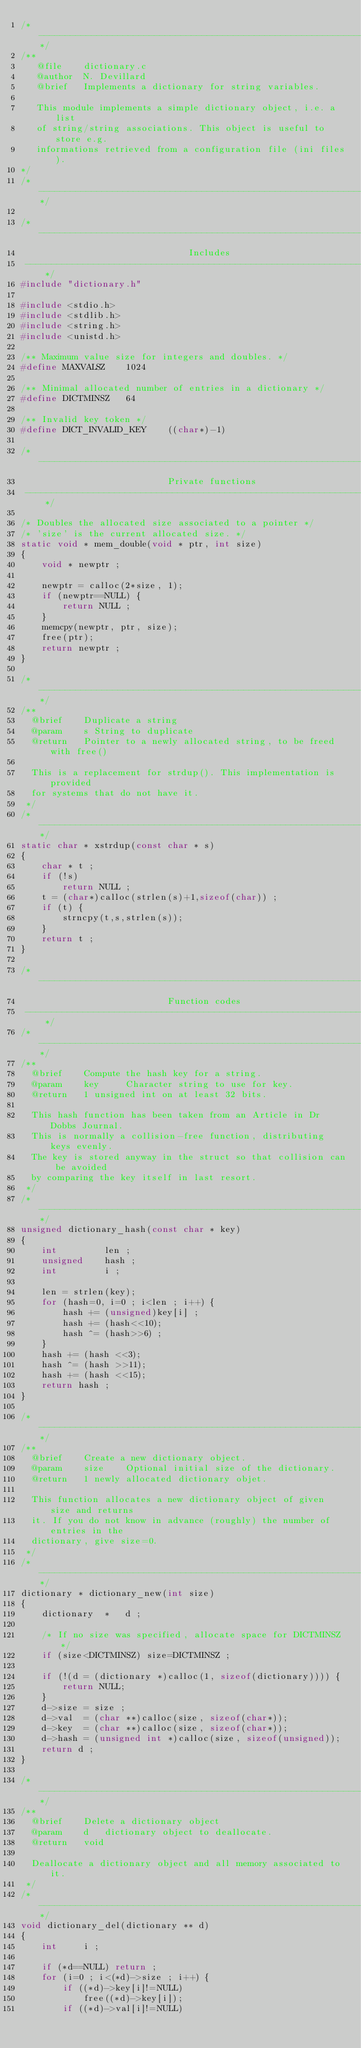Convert code to text. <code><loc_0><loc_0><loc_500><loc_500><_C_>/*-------------------------------------------------------------------------*/
/**
   @file    dictionary.c
   @author  N. Devillard
   @brief   Implements a dictionary for string variables.

   This module implements a simple dictionary object, i.e. a list
   of string/string associations. This object is useful to store e.g.
   informations retrieved from a configuration file (ini files).
*/
/*--------------------------------------------------------------------------*/

/*---------------------------------------------------------------------------
                                Includes
 ---------------------------------------------------------------------------*/
#include "dictionary.h"

#include <stdio.h>
#include <stdlib.h>
#include <string.h>
#include <unistd.h>

/** Maximum value size for integers and doubles. */
#define MAXVALSZ    1024

/** Minimal allocated number of entries in a dictionary */
#define DICTMINSZ   64

/** Invalid key token */
#define DICT_INVALID_KEY    ((char*)-1)

/*---------------------------------------------------------------------------
                            Private functions
 ---------------------------------------------------------------------------*/

/* Doubles the allocated size associated to a pointer */
/* 'size' is the current allocated size. */
static void * mem_double(void * ptr, int size)
{
    void * newptr ;

    newptr = calloc(2*size, 1);
    if (newptr==NULL) {
        return NULL ;
    }
    memcpy(newptr, ptr, size);
    free(ptr);
    return newptr ;
}

/*-------------------------------------------------------------------------*/
/**
  @brief    Duplicate a string
  @param    s String to duplicate
  @return   Pointer to a newly allocated string, to be freed with free()

  This is a replacement for strdup(). This implementation is provided
  for systems that do not have it.
 */
/*--------------------------------------------------------------------------*/
static char * xstrdup(const char * s)
{
    char * t ;
    if (!s)
        return NULL ;
    t = (char*)calloc(strlen(s)+1,sizeof(char)) ;
    if (t) {
        strncpy(t,s,strlen(s));
    }
    return t ;
}

/*---------------------------------------------------------------------------
                            Function codes
 ---------------------------------------------------------------------------*/
/*-------------------------------------------------------------------------*/
/**
  @brief    Compute the hash key for a string.
  @param    key     Character string to use for key.
  @return   1 unsigned int on at least 32 bits.

  This hash function has been taken from an Article in Dr Dobbs Journal.
  This is normally a collision-free function, distributing keys evenly.
  The key is stored anyway in the struct so that collision can be avoided
  by comparing the key itself in last resort.
 */
/*--------------------------------------------------------------------------*/
unsigned dictionary_hash(const char * key)
{
    int         len ;
    unsigned    hash ;
    int         i ;

    len = strlen(key);
    for (hash=0, i=0 ; i<len ; i++) {
        hash += (unsigned)key[i] ;
        hash += (hash<<10);
        hash ^= (hash>>6) ;
    }
    hash += (hash <<3);
    hash ^= (hash >>11);
    hash += (hash <<15);
    return hash ;
}

/*-------------------------------------------------------------------------*/
/**
  @brief    Create a new dictionary object.
  @param    size    Optional initial size of the dictionary.
  @return   1 newly allocated dictionary objet.

  This function allocates a new dictionary object of given size and returns
  it. If you do not know in advance (roughly) the number of entries in the
  dictionary, give size=0.
 */
/*--------------------------------------------------------------------------*/
dictionary * dictionary_new(int size)
{
    dictionary  *   d ;

    /* If no size was specified, allocate space for DICTMINSZ */
    if (size<DICTMINSZ) size=DICTMINSZ ;

    if (!(d = (dictionary *)calloc(1, sizeof(dictionary)))) {
        return NULL;
    }
    d->size = size ;
    d->val  = (char **)calloc(size, sizeof(char*));
    d->key  = (char **)calloc(size, sizeof(char*));
    d->hash = (unsigned int *)calloc(size, sizeof(unsigned));
    return d ;
}

/*-------------------------------------------------------------------------*/
/**
  @brief    Delete a dictionary object
  @param    d   dictionary object to deallocate.
  @return   void

  Deallocate a dictionary object and all memory associated to it.
 */
/*--------------------------------------------------------------------------*/
void dictionary_del(dictionary ** d)
{
    int     i ;

    if (*d==NULL) return ;
    for (i=0 ; i<(*d)->size ; i++) {
        if ((*d)->key[i]!=NULL)
            free((*d)->key[i]);
        if ((*d)->val[i]!=NULL)</code> 